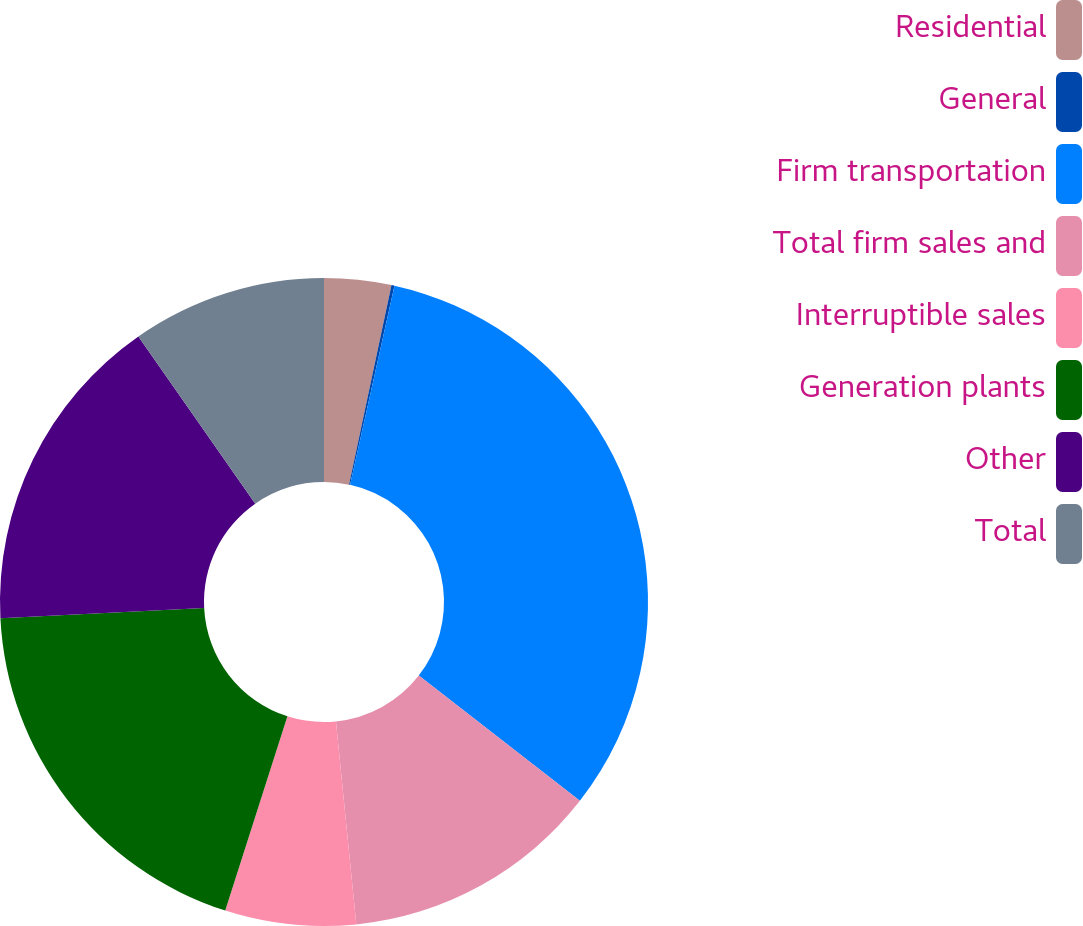Convert chart. <chart><loc_0><loc_0><loc_500><loc_500><pie_chart><fcel>Residential<fcel>General<fcel>Firm transportation<fcel>Total firm sales and<fcel>Interruptible sales<fcel>Generation plants<fcel>Other<fcel>Total<nl><fcel>3.34%<fcel>0.15%<fcel>32.02%<fcel>12.9%<fcel>6.52%<fcel>19.27%<fcel>16.09%<fcel>9.71%<nl></chart> 